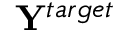Convert formula to latex. <formula><loc_0><loc_0><loc_500><loc_500>{ Y } ^ { t \arg e t }</formula> 